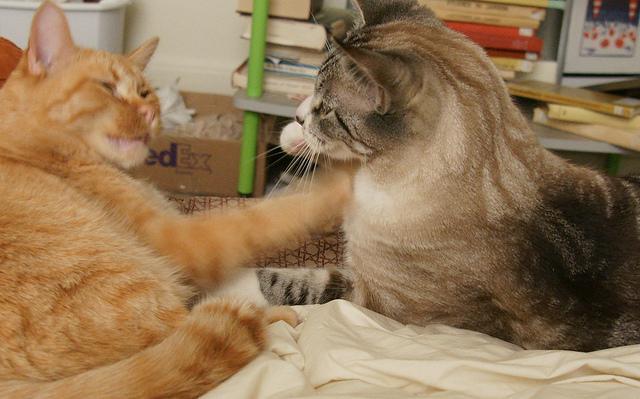How many cats are there?
Give a very brief answer. 2. How many books are in the picture?
Give a very brief answer. 3. 